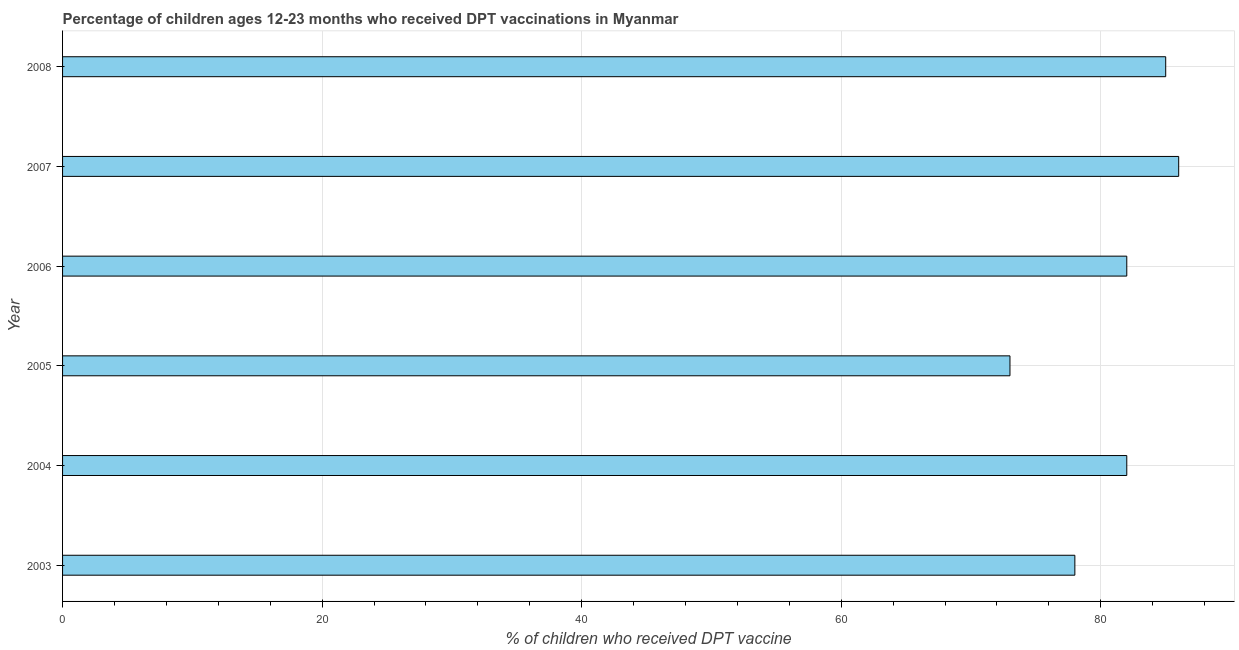Does the graph contain grids?
Offer a terse response. Yes. What is the title of the graph?
Your answer should be very brief. Percentage of children ages 12-23 months who received DPT vaccinations in Myanmar. What is the label or title of the X-axis?
Ensure brevity in your answer.  % of children who received DPT vaccine. What is the label or title of the Y-axis?
Offer a terse response. Year. What is the percentage of children who received dpt vaccine in 2008?
Give a very brief answer. 85. Across all years, what is the maximum percentage of children who received dpt vaccine?
Provide a succinct answer. 86. In which year was the percentage of children who received dpt vaccine maximum?
Give a very brief answer. 2007. What is the sum of the percentage of children who received dpt vaccine?
Offer a very short reply. 486. What is the difference between the percentage of children who received dpt vaccine in 2003 and 2008?
Your answer should be very brief. -7. What is the average percentage of children who received dpt vaccine per year?
Your response must be concise. 81. What is the median percentage of children who received dpt vaccine?
Make the answer very short. 82. In how many years, is the percentage of children who received dpt vaccine greater than 72 %?
Your answer should be compact. 6. What is the ratio of the percentage of children who received dpt vaccine in 2005 to that in 2008?
Ensure brevity in your answer.  0.86. Is the difference between the percentage of children who received dpt vaccine in 2007 and 2008 greater than the difference between any two years?
Provide a short and direct response. No. What is the difference between the highest and the second highest percentage of children who received dpt vaccine?
Make the answer very short. 1. In how many years, is the percentage of children who received dpt vaccine greater than the average percentage of children who received dpt vaccine taken over all years?
Offer a very short reply. 4. Are all the bars in the graph horizontal?
Make the answer very short. Yes. How many years are there in the graph?
Make the answer very short. 6. What is the difference between two consecutive major ticks on the X-axis?
Your response must be concise. 20. Are the values on the major ticks of X-axis written in scientific E-notation?
Provide a succinct answer. No. What is the % of children who received DPT vaccine of 2005?
Offer a terse response. 73. What is the % of children who received DPT vaccine in 2007?
Give a very brief answer. 86. What is the difference between the % of children who received DPT vaccine in 2003 and 2004?
Keep it short and to the point. -4. What is the difference between the % of children who received DPT vaccine in 2003 and 2006?
Your answer should be compact. -4. What is the difference between the % of children who received DPT vaccine in 2003 and 2007?
Keep it short and to the point. -8. What is the difference between the % of children who received DPT vaccine in 2003 and 2008?
Ensure brevity in your answer.  -7. What is the difference between the % of children who received DPT vaccine in 2004 and 2007?
Keep it short and to the point. -4. What is the difference between the % of children who received DPT vaccine in 2005 and 2006?
Offer a very short reply. -9. What is the difference between the % of children who received DPT vaccine in 2005 and 2008?
Your answer should be compact. -12. What is the difference between the % of children who received DPT vaccine in 2006 and 2008?
Make the answer very short. -3. What is the ratio of the % of children who received DPT vaccine in 2003 to that in 2004?
Keep it short and to the point. 0.95. What is the ratio of the % of children who received DPT vaccine in 2003 to that in 2005?
Make the answer very short. 1.07. What is the ratio of the % of children who received DPT vaccine in 2003 to that in 2006?
Ensure brevity in your answer.  0.95. What is the ratio of the % of children who received DPT vaccine in 2003 to that in 2007?
Provide a succinct answer. 0.91. What is the ratio of the % of children who received DPT vaccine in 2003 to that in 2008?
Make the answer very short. 0.92. What is the ratio of the % of children who received DPT vaccine in 2004 to that in 2005?
Ensure brevity in your answer.  1.12. What is the ratio of the % of children who received DPT vaccine in 2004 to that in 2006?
Provide a succinct answer. 1. What is the ratio of the % of children who received DPT vaccine in 2004 to that in 2007?
Ensure brevity in your answer.  0.95. What is the ratio of the % of children who received DPT vaccine in 2005 to that in 2006?
Provide a short and direct response. 0.89. What is the ratio of the % of children who received DPT vaccine in 2005 to that in 2007?
Ensure brevity in your answer.  0.85. What is the ratio of the % of children who received DPT vaccine in 2005 to that in 2008?
Make the answer very short. 0.86. What is the ratio of the % of children who received DPT vaccine in 2006 to that in 2007?
Your answer should be very brief. 0.95. What is the ratio of the % of children who received DPT vaccine in 2007 to that in 2008?
Ensure brevity in your answer.  1.01. 